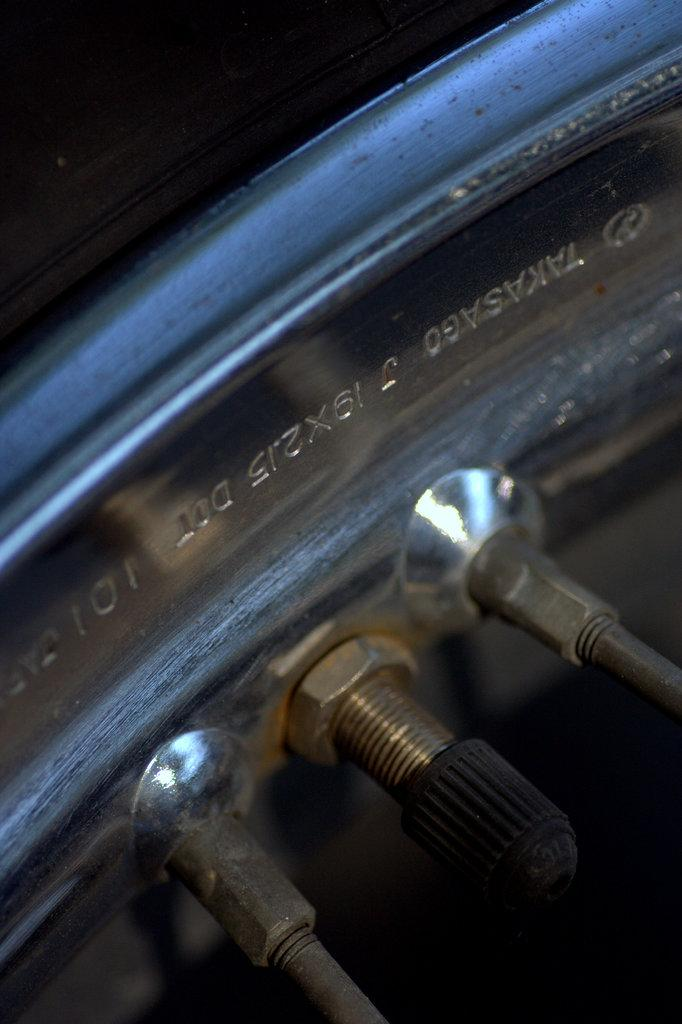What is the main subject of the image? The main subject of the image consists of a rim and spokes. Can you describe the rim in the image? The image consists of a rim, but no further details about the rim are provided. How many spokes are visible in the image? The image consists of spokes, but the number of spokes is not specified. What type of skin condition can be seen on the ducks in the image? There are no ducks present in the image, so it is not possible to determine if any skin conditions are visible. 